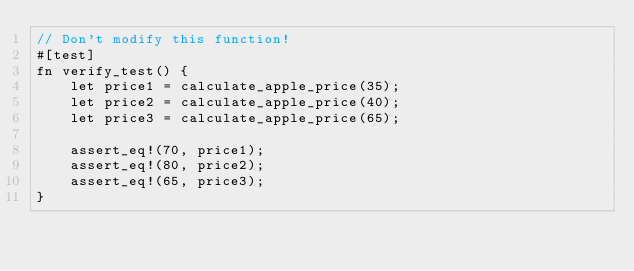<code> <loc_0><loc_0><loc_500><loc_500><_Rust_>// Don't modify this function!
#[test]
fn verify_test() {
    let price1 = calculate_apple_price(35);
    let price2 = calculate_apple_price(40);
    let price3 = calculate_apple_price(65);

    assert_eq!(70, price1);
    assert_eq!(80, price2);
    assert_eq!(65, price3);
}
</code> 